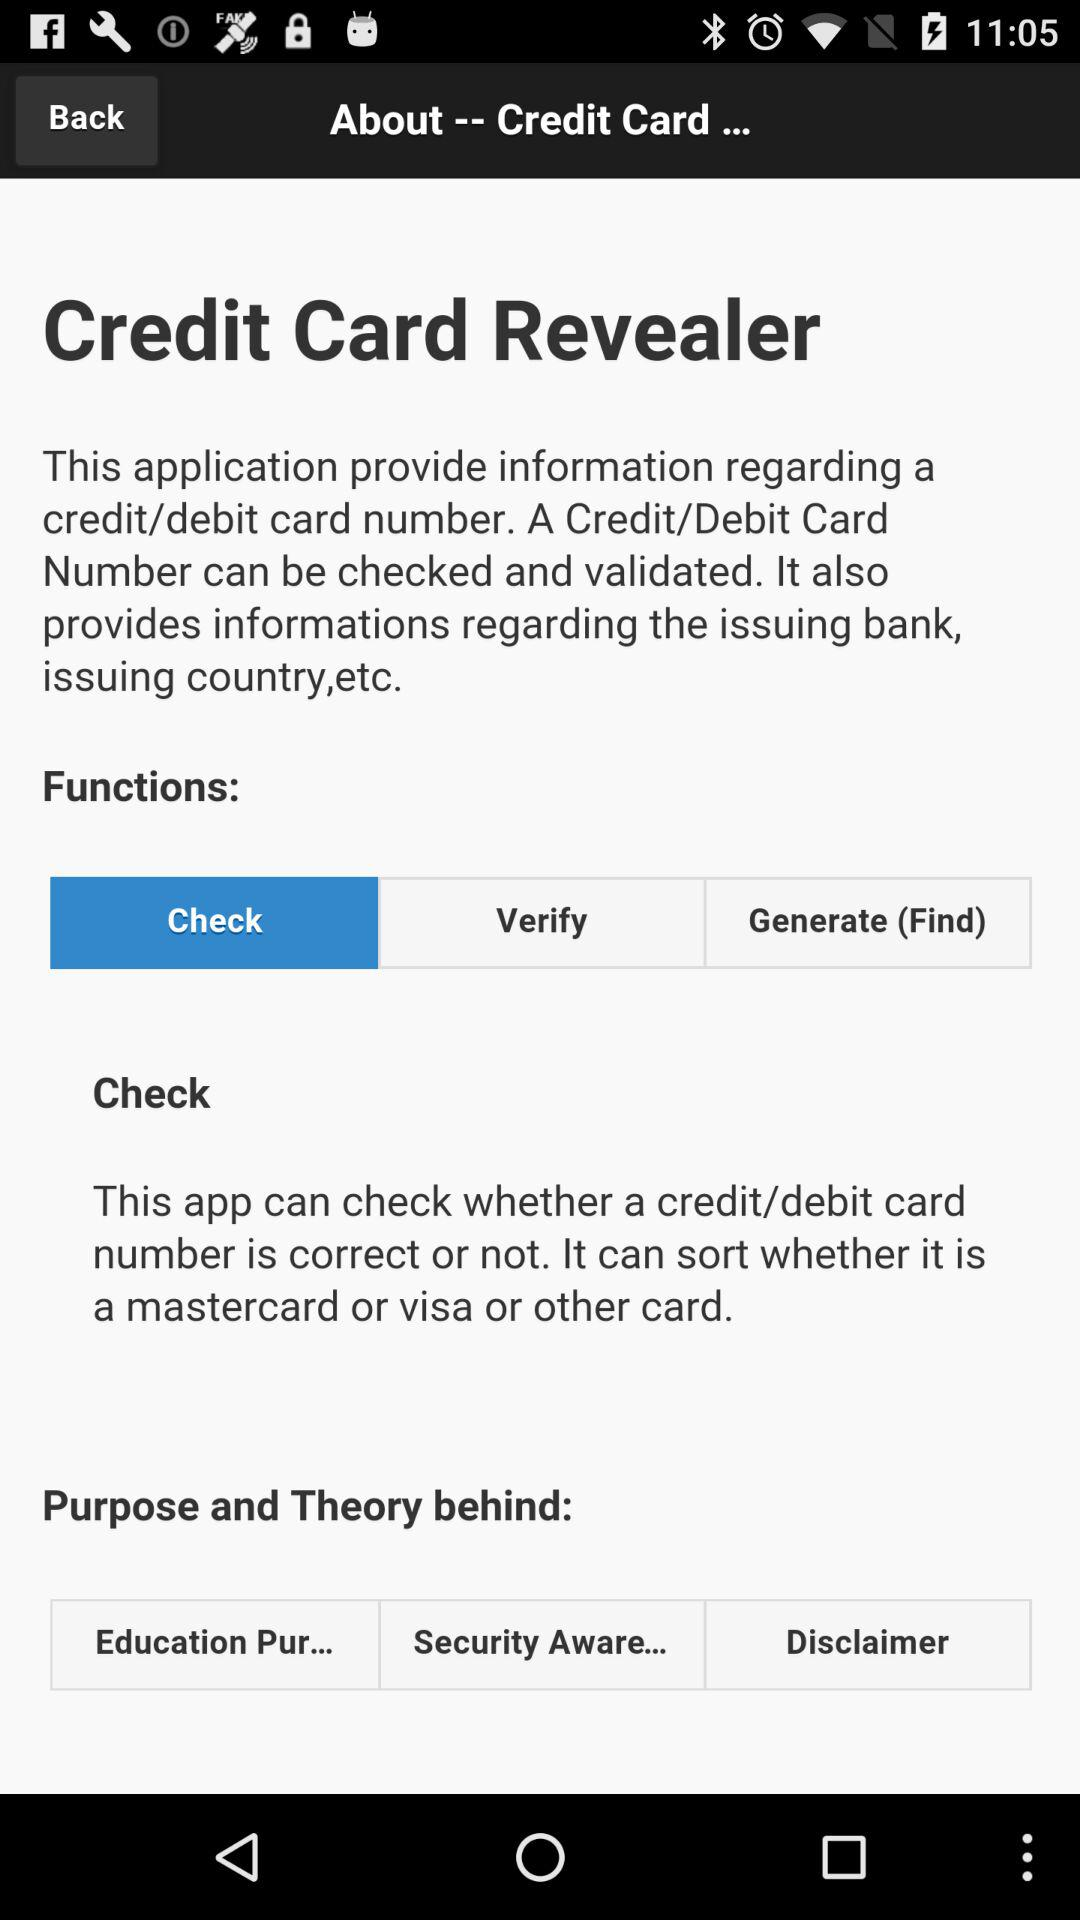What function has been selected? The selected function is "Check". 